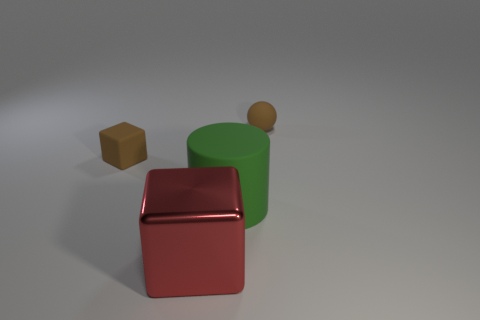How do the textures of the objects differ? The three objects in the image display unique textures. The matte ball and block have a non-reflective, flat finish, while the cube exhibits a shiny, reflective surface, indicative of a metallic or polished material. 